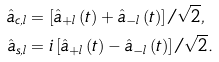Convert formula to latex. <formula><loc_0><loc_0><loc_500><loc_500>\hat { a } _ { c , l } & = \left [ \hat { a } _ { + l } \left ( t \right ) + \hat { a } _ { - l } \left ( t \right ) \right ] / \sqrt { 2 } , \\ \hat { a } _ { s , l } & = i \left [ \hat { a } _ { + l } \left ( t \right ) - \hat { a } _ { - l } \left ( t \right ) \right ] / \sqrt { 2 } .</formula> 